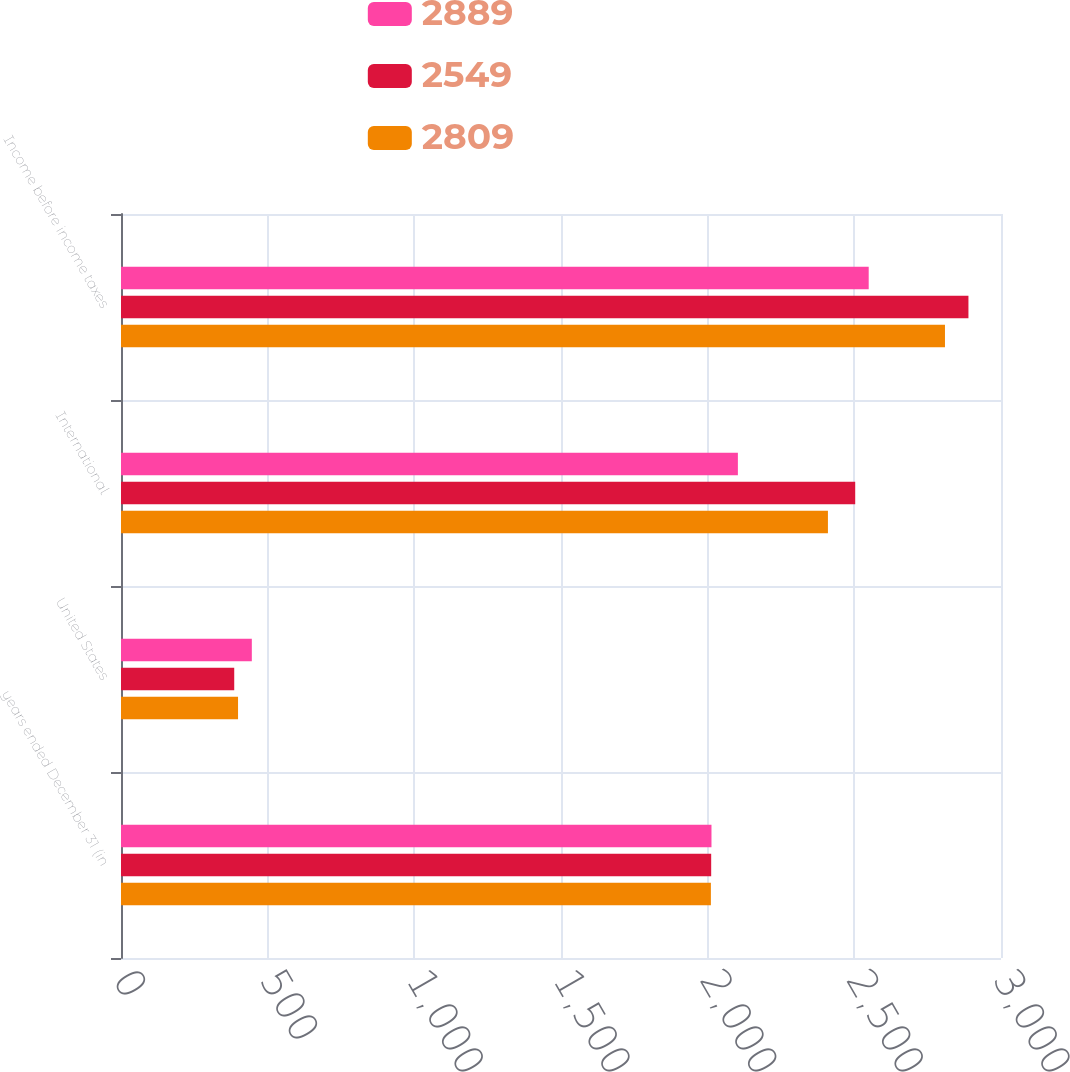<chart> <loc_0><loc_0><loc_500><loc_500><stacked_bar_chart><ecel><fcel>years ended December 31 (in<fcel>United States<fcel>International<fcel>Income before income taxes<nl><fcel>2889<fcel>2013<fcel>446<fcel>2103<fcel>2549<nl><fcel>2549<fcel>2012<fcel>386<fcel>2503<fcel>2889<nl><fcel>2809<fcel>2011<fcel>399<fcel>2410<fcel>2809<nl></chart> 